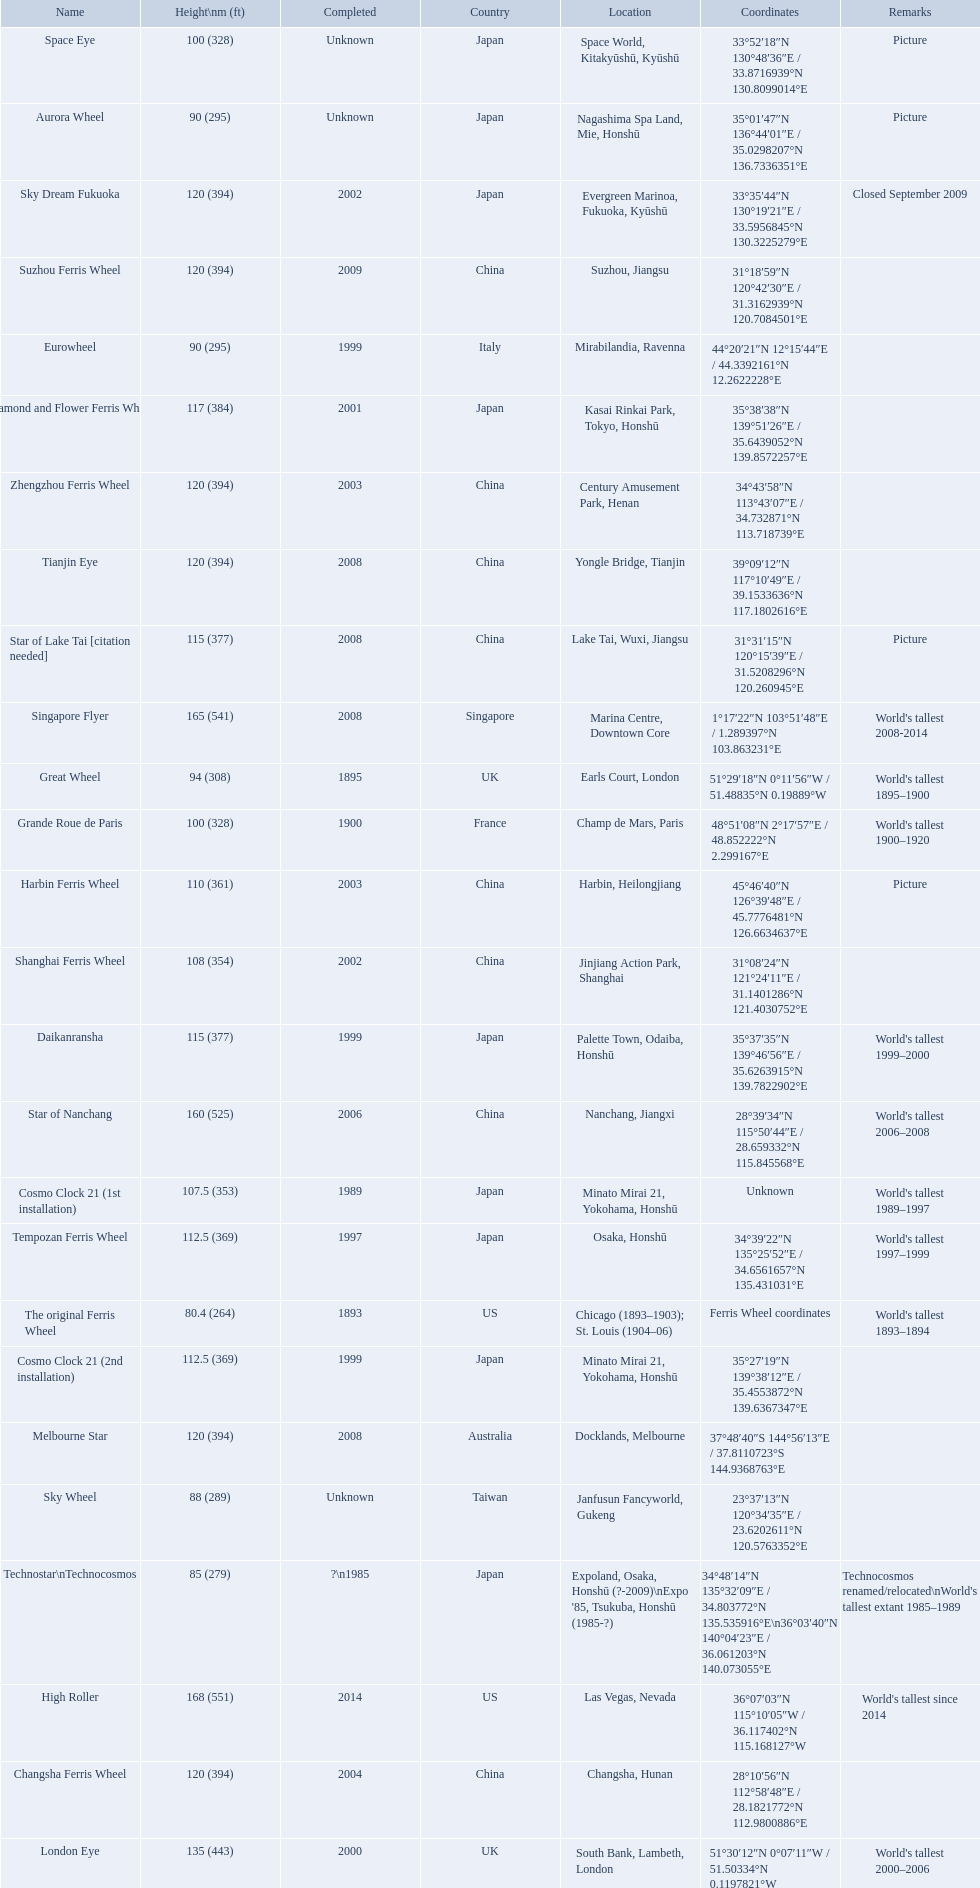How tall is the roller coaster star of nanchang? 165 (541). When was the roller coaster star of nanchang completed? 2008. What is the name of the oldest roller coaster? Star of Nanchang. 